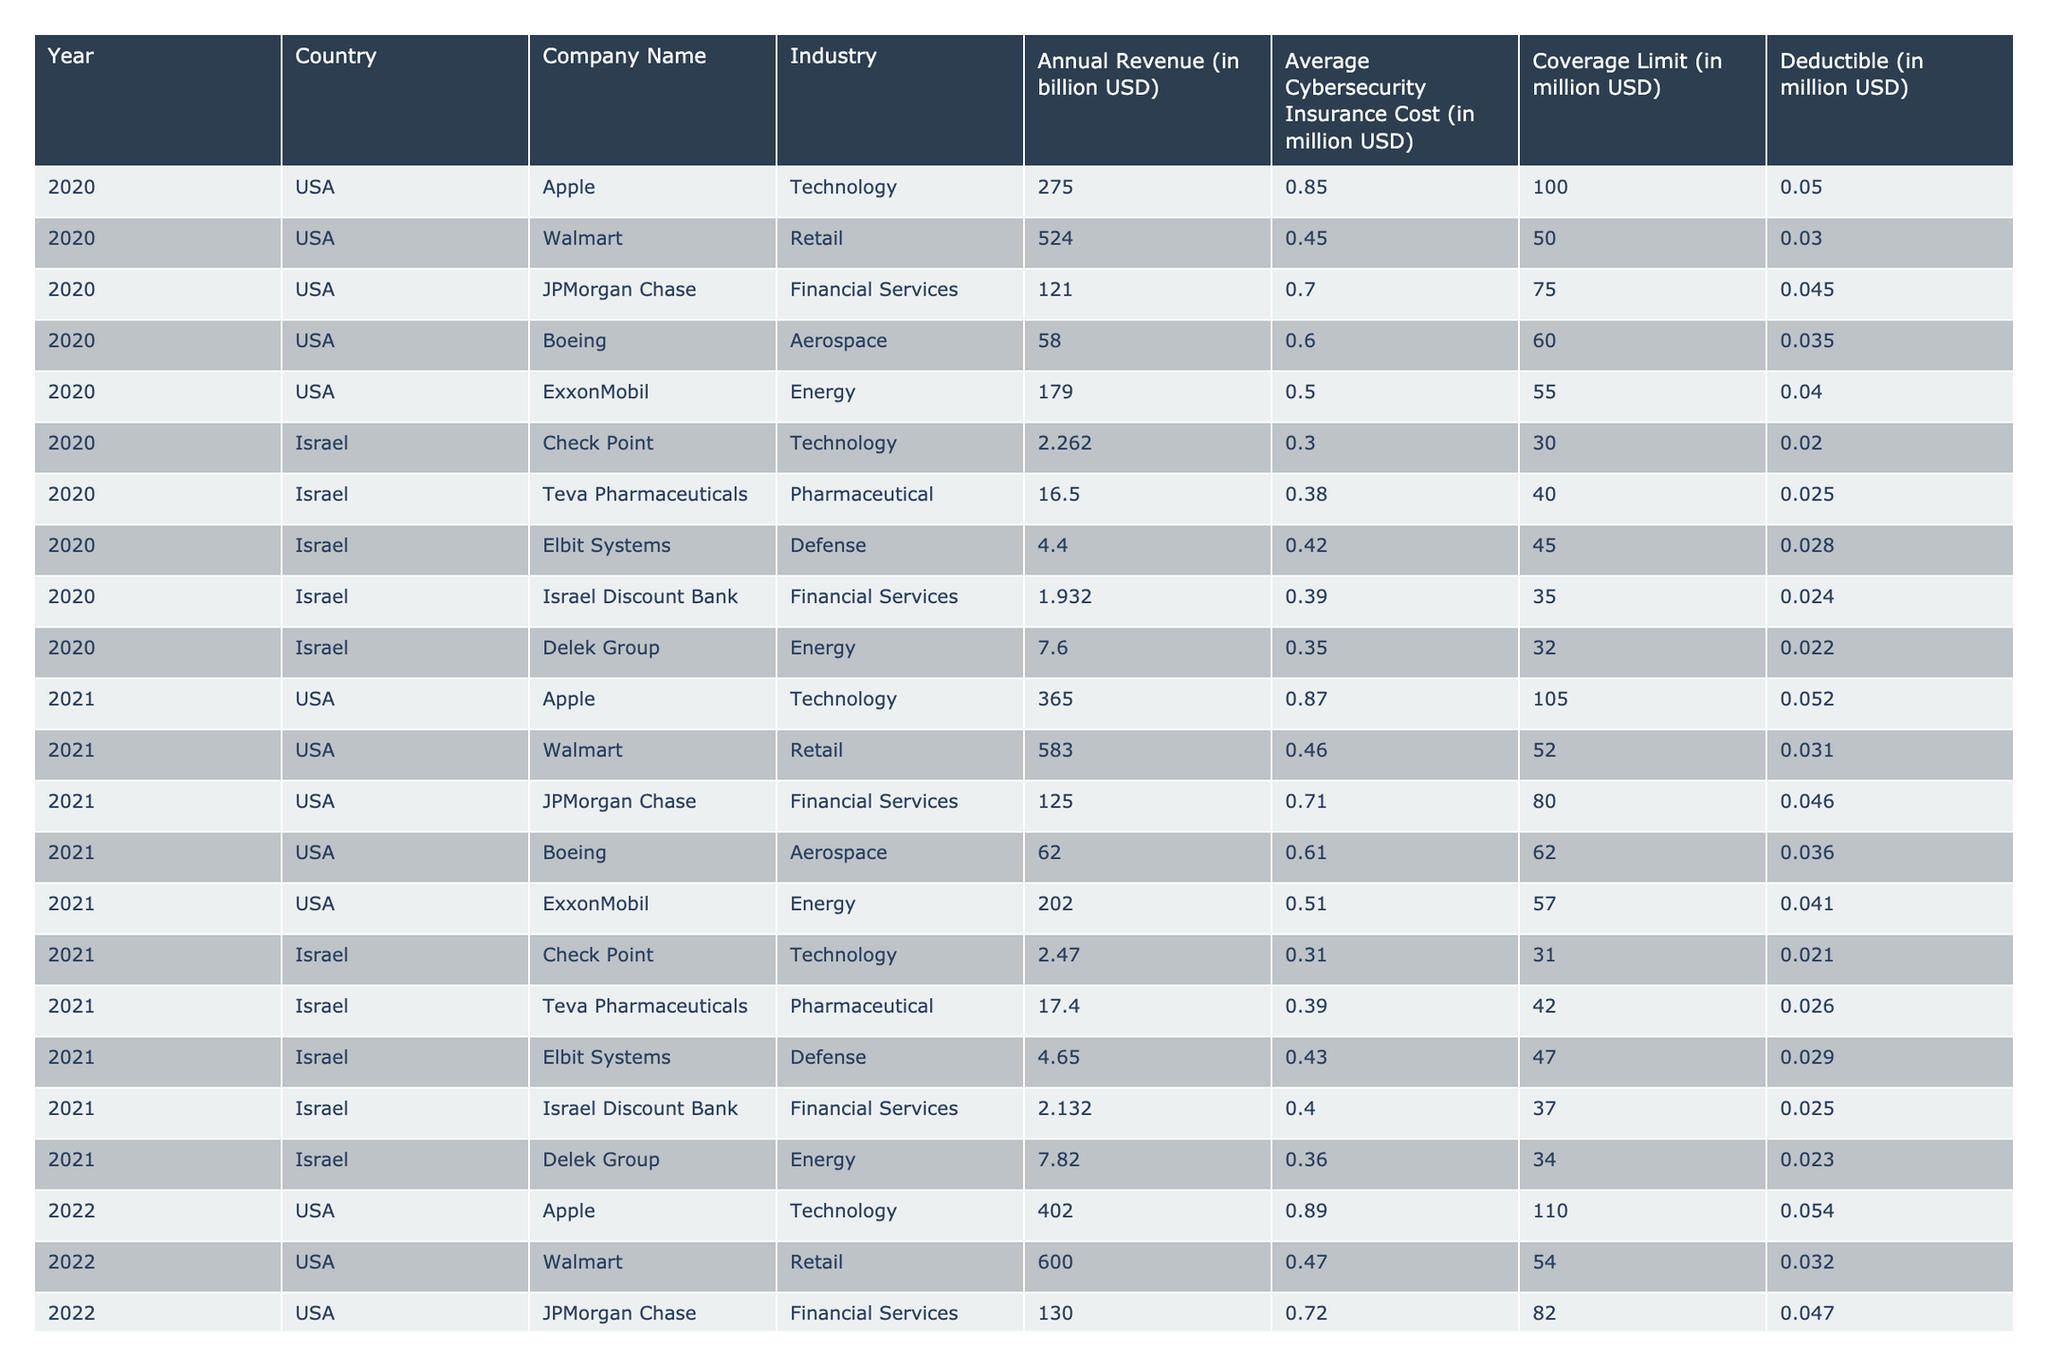What is the average cybersecurity insurance cost for US companies in 2021? In 2021, the average cybersecurity insurance costs for US companies are as follows: Apple 870, Walmart 460, JPMorgan Chase 710, Boeing 610, and ExxonMobil 510. To find the average, we sum these costs: 870 + 460 + 710 + 610 + 510 = 3160. Then, we divide by the number of companies (5): 3160 / 5 = 632.
Answer: 632 Which Israeli company had the highest average cybersecurity insurance cost in 2022? In 2022, the average cybersecurity insurance costs for Israeli companies are Check Point 320, Teva Pharmaceuticals 400, Elbit Systems 440, Israel Discount Bank 410, and Delek Group 370. Elbit Systems has the highest cost of 440.
Answer: Elbit Systems Is the average deductible for US banks in 2020 higher than that for Israeli banks? In 2020, the deductible for JPMorgan Chase (US) is 45, while Israel Discount Bank's deductible (Israel) is 24. Since 45 is greater than 24, the average deductible for US banks is indeed higher.
Answer: Yes What is the total revenue of Israeli companies in the technology sector over the three years? The companies Check Point and Elbit Systems are the only ones in the technology sector. Their revenues are: for Check Point 2262 in 2020, 2470 in 2021, and 2640 in 2022 total is 2262 + 2470 + 2640 = 7372. The total revenue for Elbit Systems is: 4400 (2020) + 4650 (2021) + 4870 (2022) total is 4400 + 4650 + 4870 = 13920. Summing these gives: 7372 + 13920 = 21292.
Answer: 21292 Which country had a higher average coverage limit for financial services companies in 2021? In 2021, the coverage limit for JPMorgan Chase (US) is 80 and for Israel Discount Bank (Israel) is 37. Since 80 is greater than 37, the US financial services companies had a higher average coverage limit.
Answer: USA What is the average annual revenue for US retail companies from 2020 to 2022? The retail companies are Walmart for 2020 (524), 2021 (583), and 2022 (600). Their total revenue is 524 + 583 + 600 = 1707. To find the average, we divide by the number of years (3): 1707 / 3 = 569.
Answer: 569 